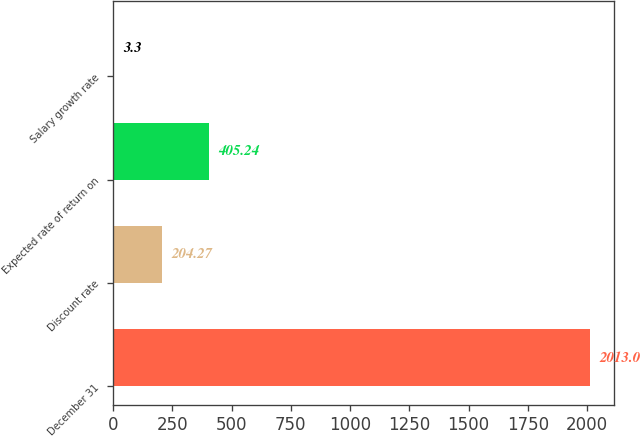Convert chart. <chart><loc_0><loc_0><loc_500><loc_500><bar_chart><fcel>December 31<fcel>Discount rate<fcel>Expected rate of return on<fcel>Salary growth rate<nl><fcel>2013<fcel>204.27<fcel>405.24<fcel>3.3<nl></chart> 